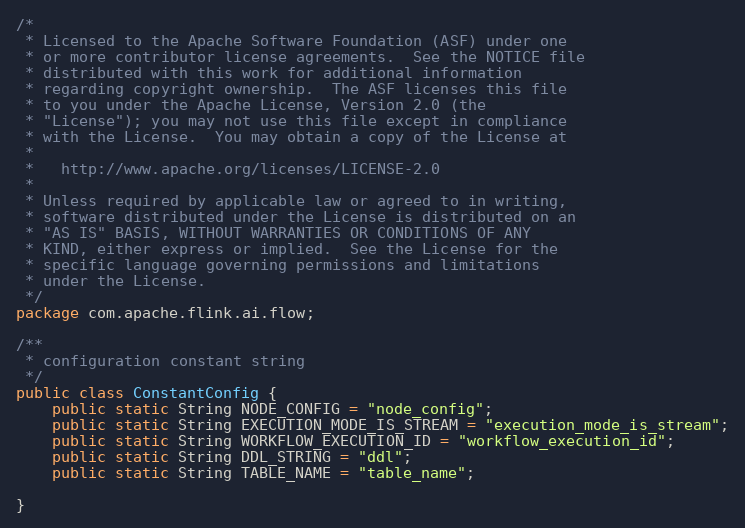Convert code to text. <code><loc_0><loc_0><loc_500><loc_500><_Java_>/*
 * Licensed to the Apache Software Foundation (ASF) under one
 * or more contributor license agreements.  See the NOTICE file
 * distributed with this work for additional information
 * regarding copyright ownership.  The ASF licenses this file
 * to you under the Apache License, Version 2.0 (the
 * "License"); you may not use this file except in compliance
 * with the License.  You may obtain a copy of the License at
 *
 *   http://www.apache.org/licenses/LICENSE-2.0
 *
 * Unless required by applicable law or agreed to in writing,
 * software distributed under the License is distributed on an
 * "AS IS" BASIS, WITHOUT WARRANTIES OR CONDITIONS OF ANY
 * KIND, either express or implied.  See the License for the
 * specific language governing permissions and limitations
 * under the License.
 */
package com.apache.flink.ai.flow;

/**
 * configuration constant string
 */
public class ConstantConfig {
    public static String NODE_CONFIG = "node_config";
    public static String EXECUTION_MODE_IS_STREAM = "execution_mode_is_stream";
    public static String WORKFLOW_EXECUTION_ID = "workflow_execution_id";
    public static String DDL_STRING = "ddl";
    public static String TABLE_NAME = "table_name";

}
</code> 